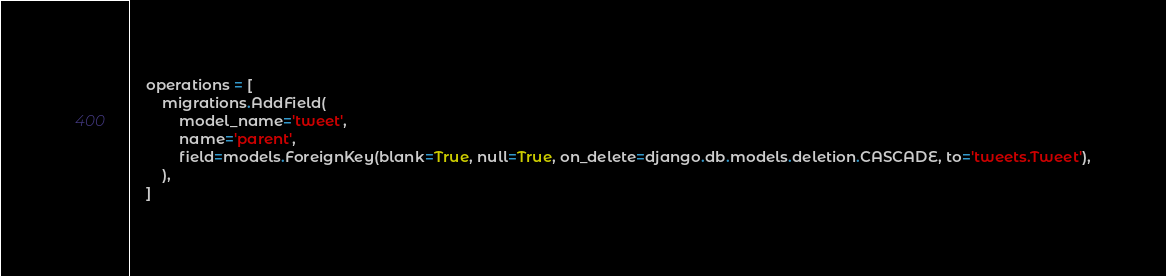<code> <loc_0><loc_0><loc_500><loc_500><_Python_>    operations = [
        migrations.AddField(
            model_name='tweet',
            name='parent',
            field=models.ForeignKey(blank=True, null=True, on_delete=django.db.models.deletion.CASCADE, to='tweets.Tweet'),
        ),
    ]
</code> 